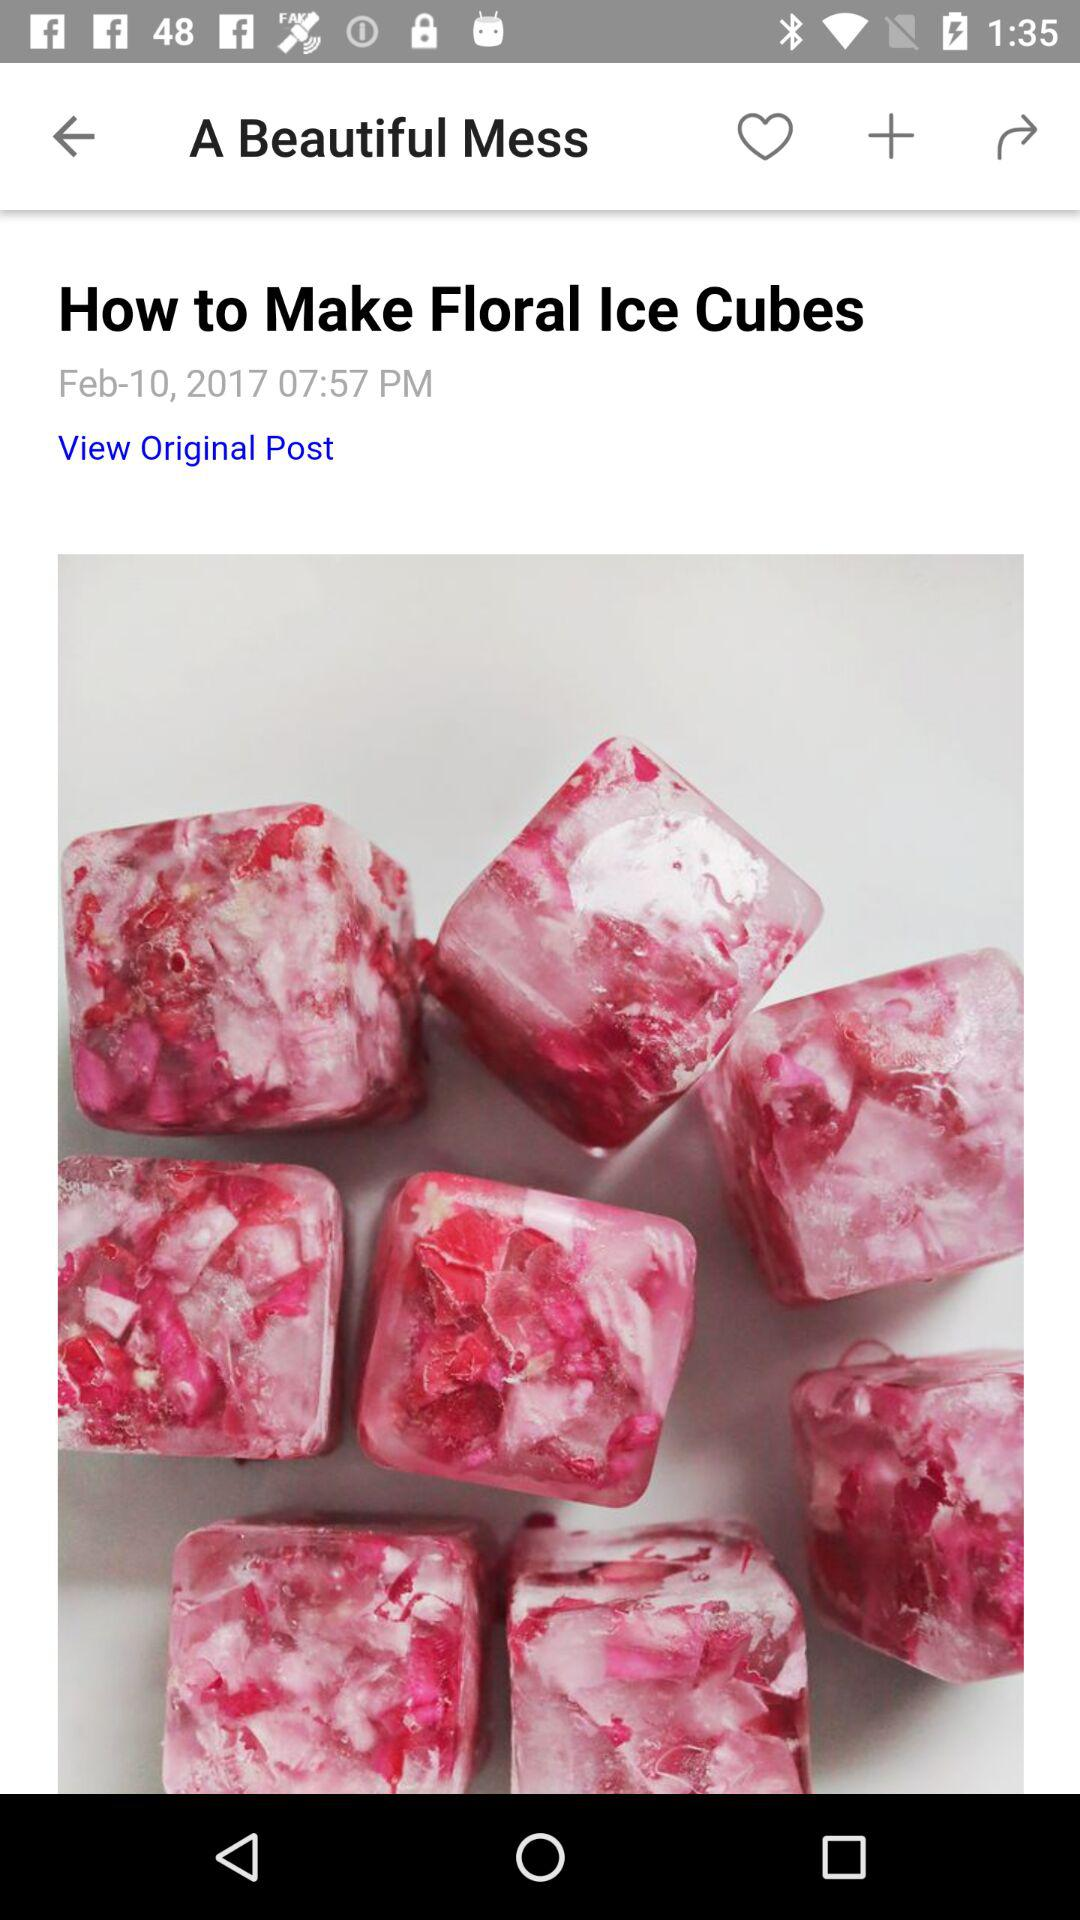What is the date the post was published? The date is February 10. 